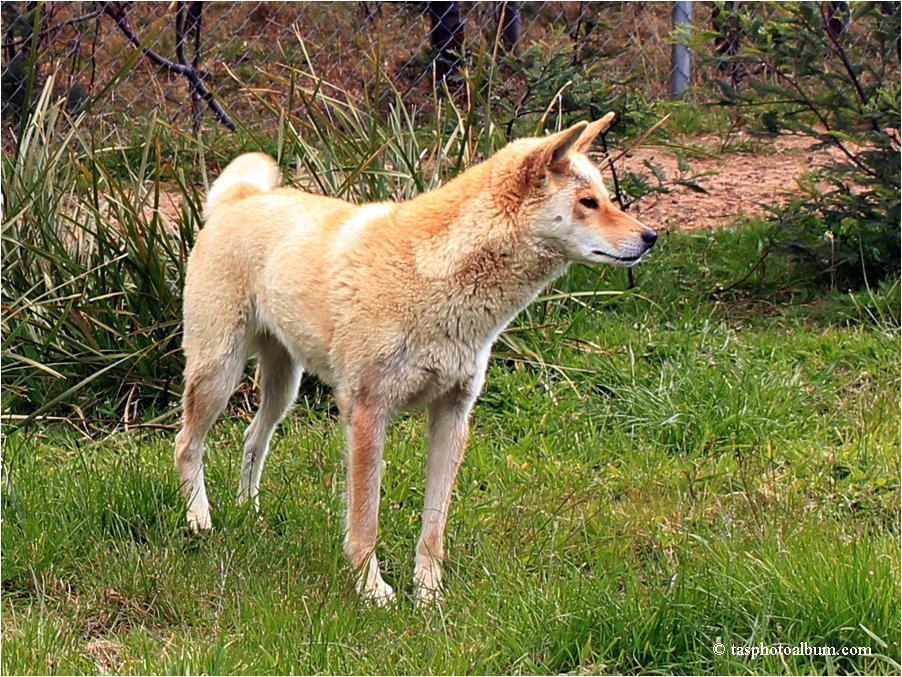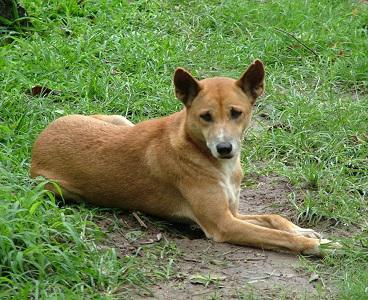The first image is the image on the left, the second image is the image on the right. Examine the images to the left and right. Is the description "An image shows at least one dog looking completely to the side." accurate? Answer yes or no. Yes. 